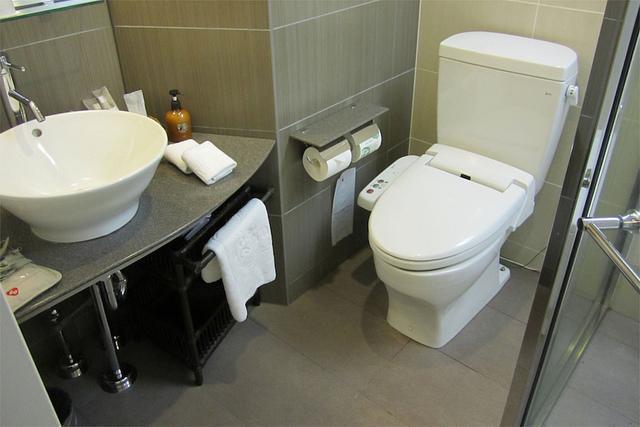What do the buttons to the right of the tissue rolls control?
Indicate the correct response and explain using: 'Answer: answer
Rationale: rationale.'
Options: Temperature, lights, toilet, radio. Answer: toilet.
Rationale: The buttons are for the toilet. 